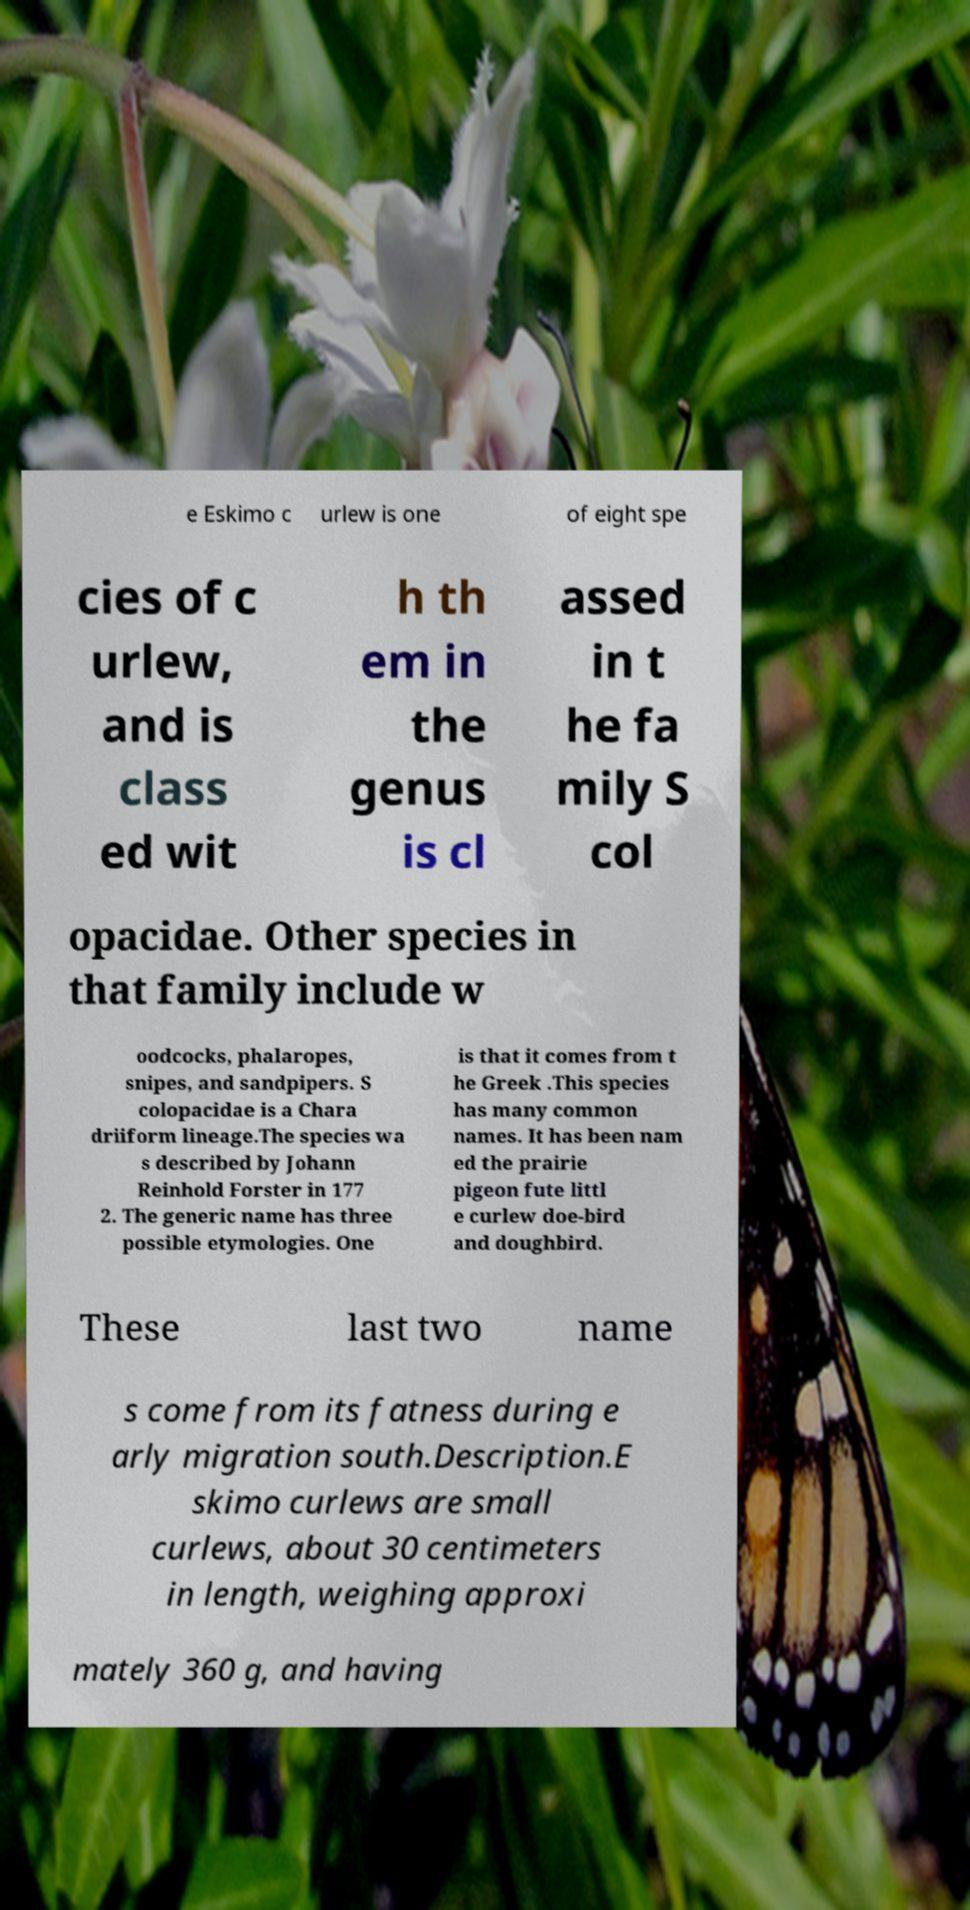For documentation purposes, I need the text within this image transcribed. Could you provide that? e Eskimo c urlew is one of eight spe cies of c urlew, and is class ed wit h th em in the genus is cl assed in t he fa mily S col opacidae. Other species in that family include w oodcocks, phalaropes, snipes, and sandpipers. S colopacidae is a Chara driiform lineage.The species wa s described by Johann Reinhold Forster in 177 2. The generic name has three possible etymologies. One is that it comes from t he Greek .This species has many common names. It has been nam ed the prairie pigeon fute littl e curlew doe-bird and doughbird. These last two name s come from its fatness during e arly migration south.Description.E skimo curlews are small curlews, about 30 centimeters in length, weighing approxi mately 360 g, and having 